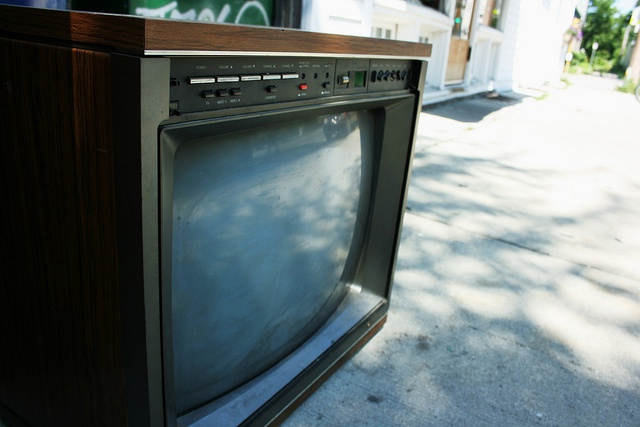Describe the objects in this image and their specific colors. I can see a tv in navy, black, blue, and gray tones in this image. 